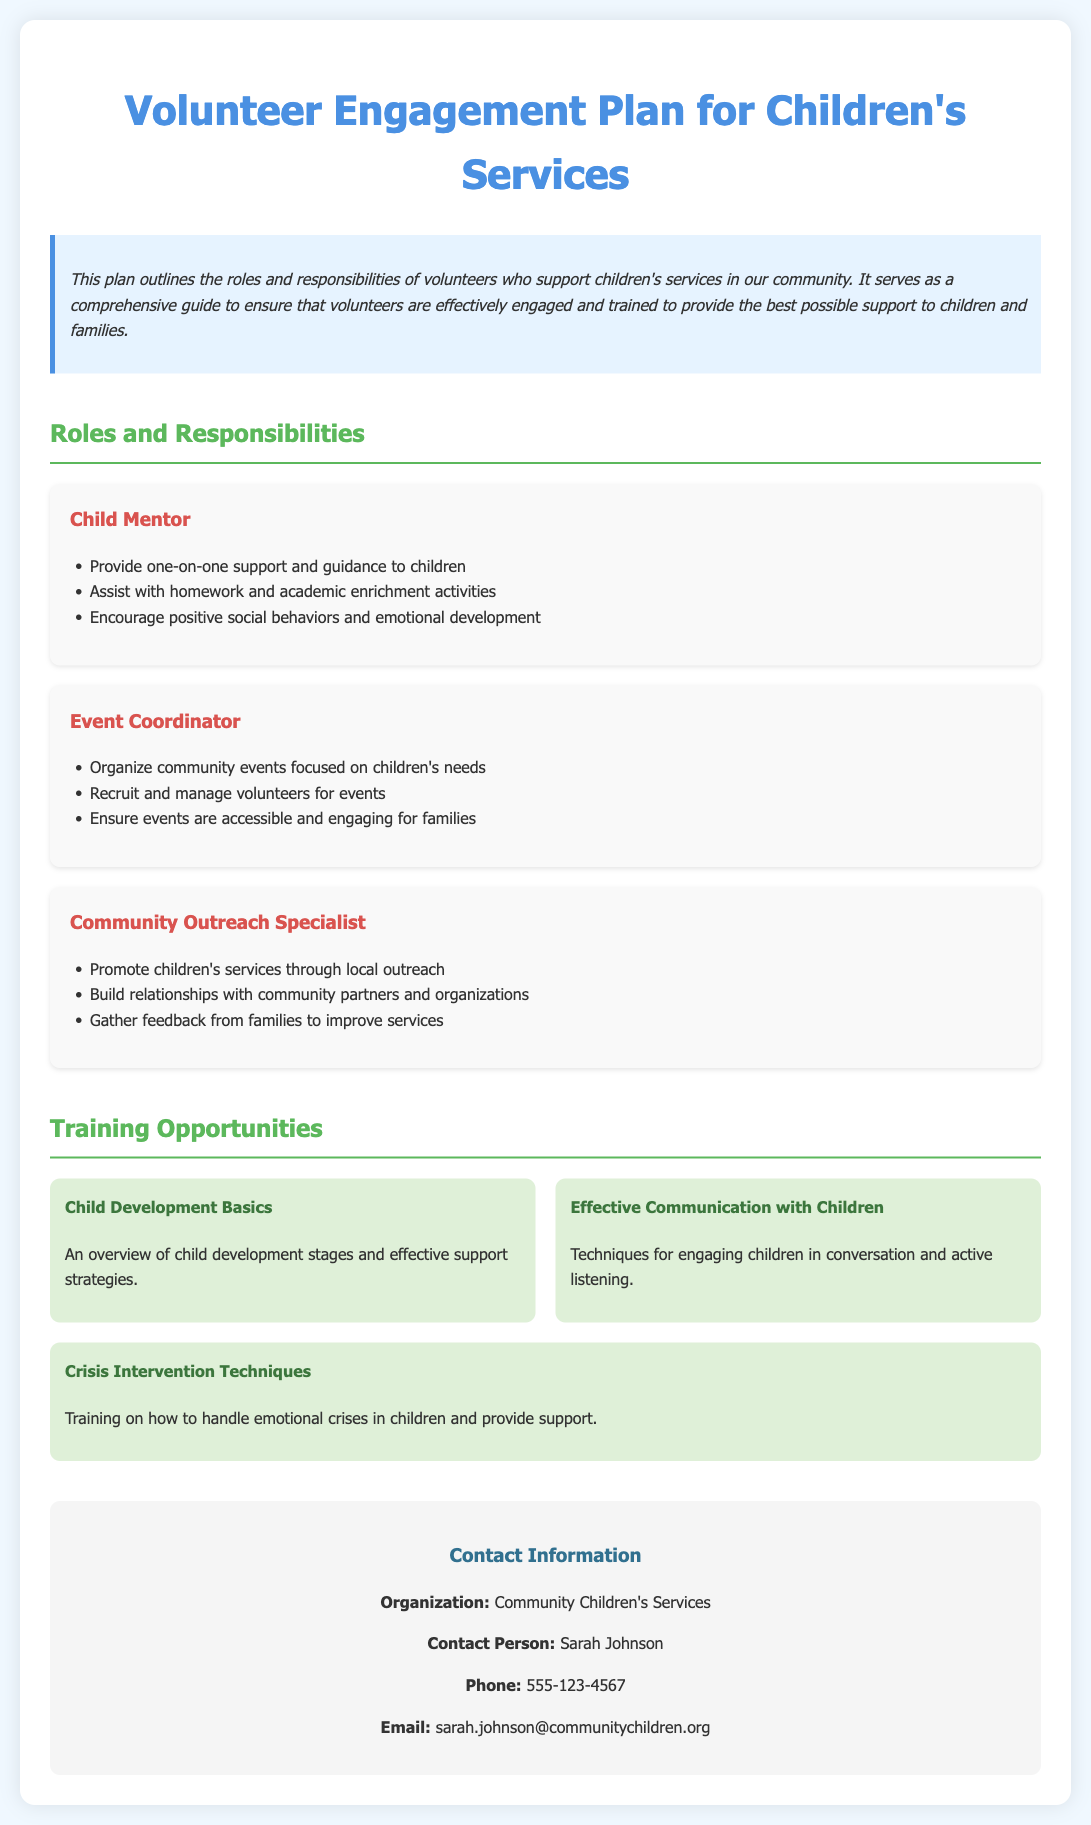what is the title of the document? The title of the document is specified in the header section of the HTML, which indicates its main topic.
Answer: Volunteer Engagement Plan for Children's Services who is the contact person listed in the document? The contact person is mentioned in the contact information section of the document.
Answer: Sarah Johnson what training opportunity focuses on communication? The specific training opportunity is indicated in the training section, detailing the skills being taught.
Answer: Effective Communication with Children how many roles are described in the document? The number of roles can be counted from the sections dedicated to volunteer roles and responsibilities.
Answer: 3 what is the main purpose of the volunteer engagement plan? The purpose is explained in the introductory paragraph, which outlines the goals of the engagement plan.
Answer: To ensure that volunteers are effectively engaged and trained which role is responsible for organizing community events? This can be identified by reading the responsibilities listed under the relevant role in the document.
Answer: Event Coordinator what is one responsibility of a Child Mentor? The specific responsibility can be found in the list of duties for this particular role.
Answer: Provide one-on-one support and guidance to children how many training opportunities are listed in total? The total number can be determined by counting the training items in the training section.
Answer: 3 